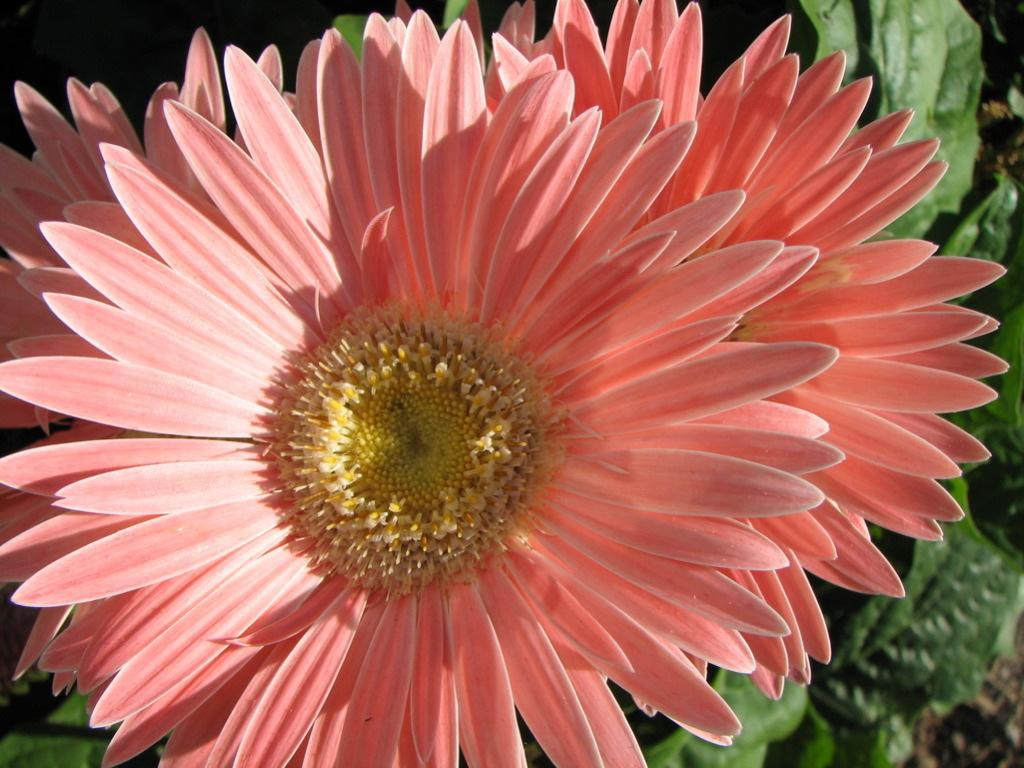What type of plants can be seen in the image? There are flowers and a group of leaves in the image. Can you describe the flowers in the image? Unfortunately, the facts provided do not give specific details about the flowers. How many groups of leaves are visible in the image? The facts provided only mention "a group of leaves," so it is not possible to determine the exact number. What type of honey can be seen dripping from the flowers in the image? There is no honey present in the image; it only features flowers and a group of leaves. Is there a dog visible in the image? No, there is no dog present in the image. 